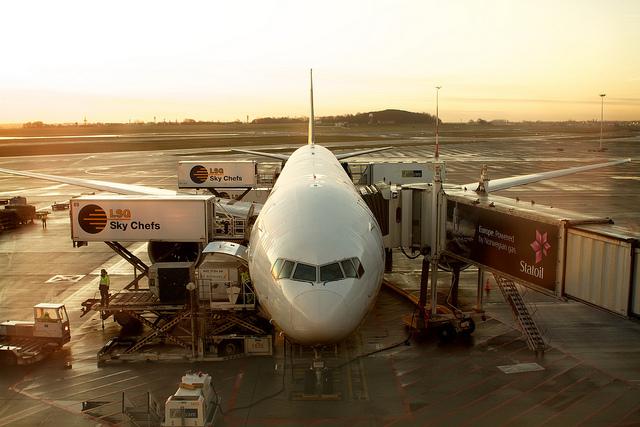Is this a passenger plane?
Short answer required. Yes. Is the sun setting?
Concise answer only. Yes. Is this plane ready for takeoff?
Short answer required. No. 